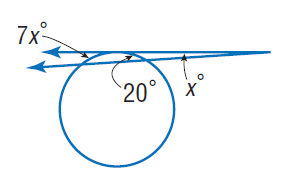Answer the mathemtical geometry problem and directly provide the correct option letter.
Question: Find x. Assume that any segment that appears to be tangent is tangent.
Choices: A: 4 B: 7 C: 20 D: 28 A 